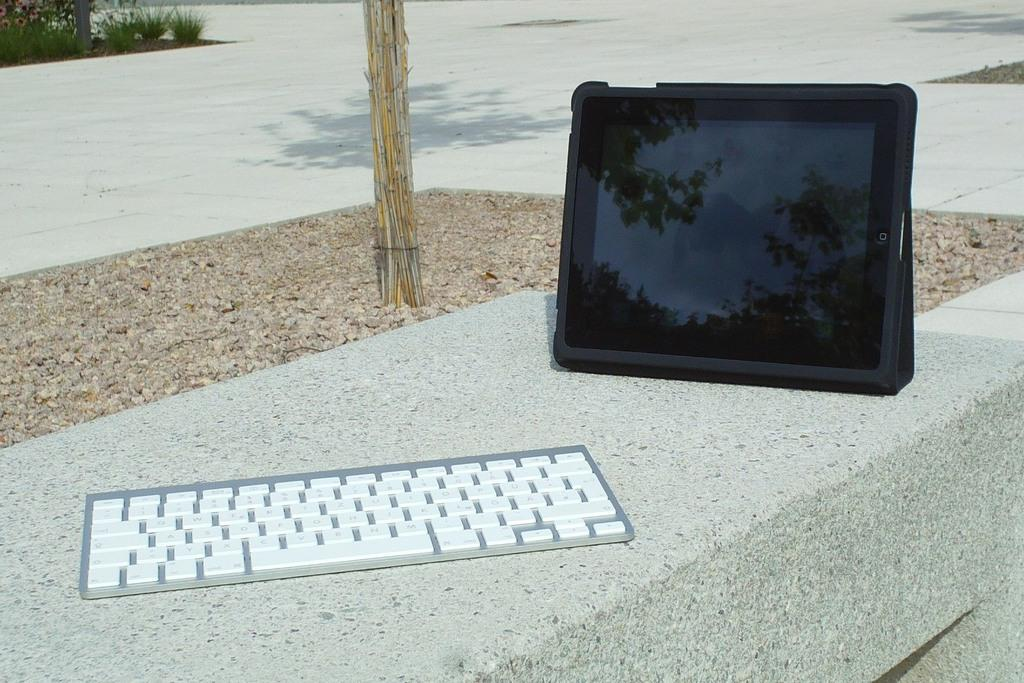What electronic device is visible in the image? There is an iPad in the image. What is used in conjunction with the iPad? There is a keyboard in the image. What type of natural elements can be seen in the image? There are plants and stones in the image. What type of marble is being used to build the structure in the image? There is no structure or marble present in the image; it features an iPad, a keyboard, plants, and stones. 